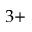<formula> <loc_0><loc_0><loc_500><loc_500>3 +</formula> 